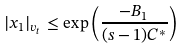Convert formula to latex. <formula><loc_0><loc_0><loc_500><loc_500>| x _ { 1 } | _ { v _ { t } } \leq \exp \left ( \frac { - B _ { 1 } } { ( s - 1 ) C ^ { * } } \right )</formula> 